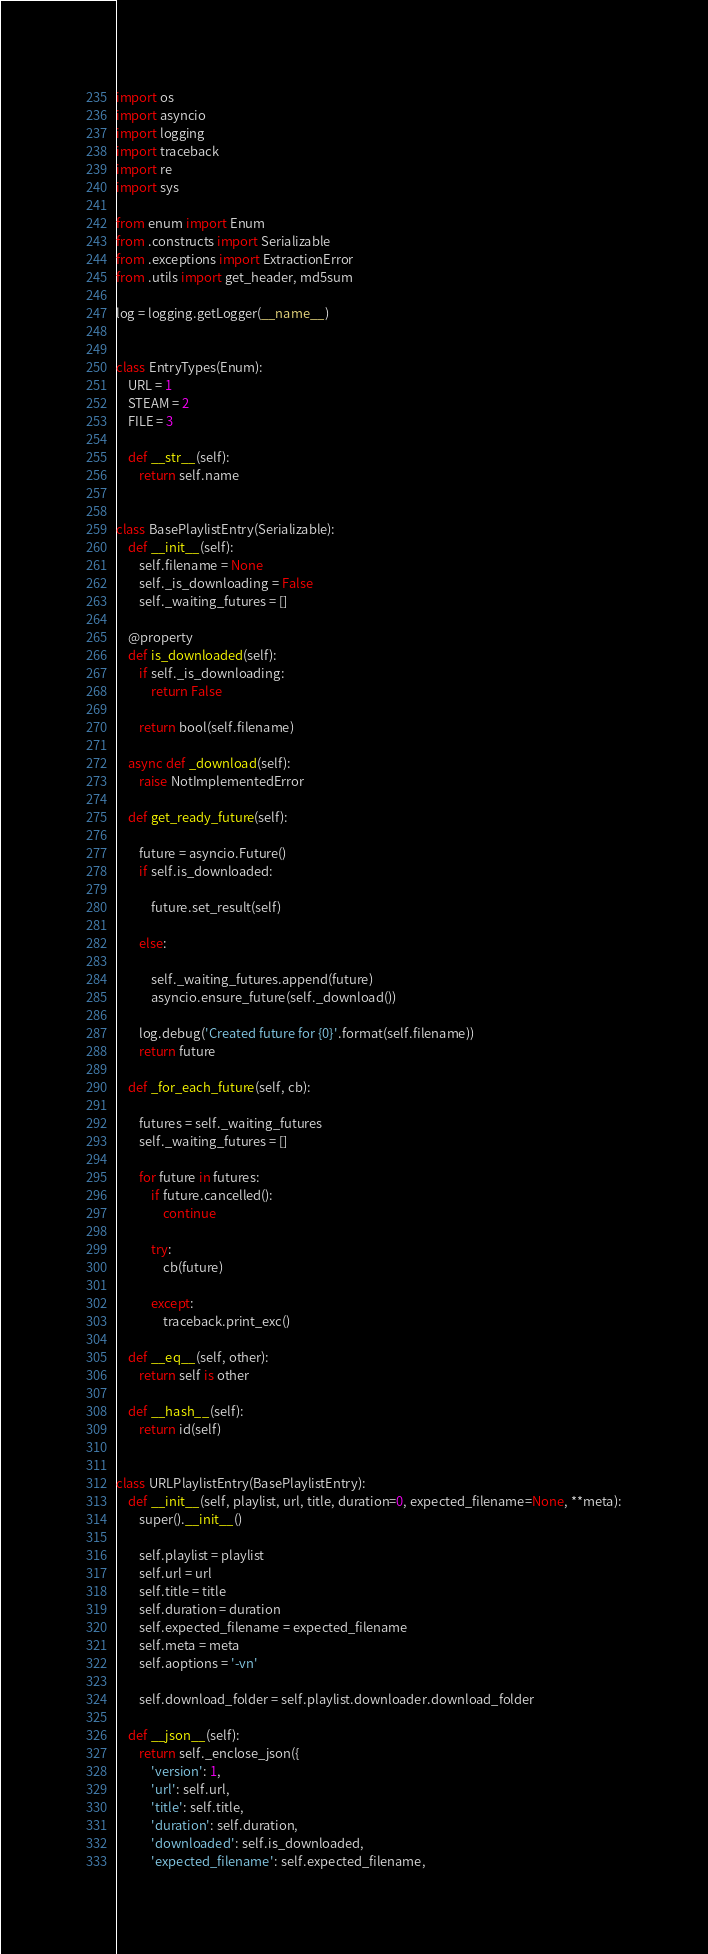Convert code to text. <code><loc_0><loc_0><loc_500><loc_500><_Python_>import os
import asyncio
import logging
import traceback
import re
import sys

from enum import Enum
from .constructs import Serializable
from .exceptions import ExtractionError
from .utils import get_header, md5sum

log = logging.getLogger(__name__)


class EntryTypes(Enum):
    URL = 1
    STEAM = 2
    FILE = 3

    def __str__(self):
        return self.name


class BasePlaylistEntry(Serializable):
    def __init__(self):
        self.filename = None
        self._is_downloading = False
        self._waiting_futures = []

    @property
    def is_downloaded(self):
        if self._is_downloading:
            return False

        return bool(self.filename)

    async def _download(self):
        raise NotImplementedError

    def get_ready_future(self):

        future = asyncio.Future()
        if self.is_downloaded:
            
            future.set_result(self)

        else:
            
            self._waiting_futures.append(future)
            asyncio.ensure_future(self._download())

        log.debug('Created future for {0}'.format(self.filename))
        return future

    def _for_each_future(self, cb):

        futures = self._waiting_futures
        self._waiting_futures = []

        for future in futures:
            if future.cancelled():
                continue

            try:
                cb(future)

            except:
                traceback.print_exc()

    def __eq__(self, other):
        return self is other

    def __hash__(self):
        return id(self)


class URLPlaylistEntry(BasePlaylistEntry):
    def __init__(self, playlist, url, title, duration=0, expected_filename=None, **meta):
        super().__init__()

        self.playlist = playlist
        self.url = url
        self.title = title
        self.duration = duration
        self.expected_filename = expected_filename
        self.meta = meta
        self.aoptions = '-vn'

        self.download_folder = self.playlist.downloader.download_folder

    def __json__(self):
        return self._enclose_json({
            'version': 1,
            'url': self.url,
            'title': self.title,
            'duration': self.duration,
            'downloaded': self.is_downloaded,
            'expected_filename': self.expected_filename,</code> 